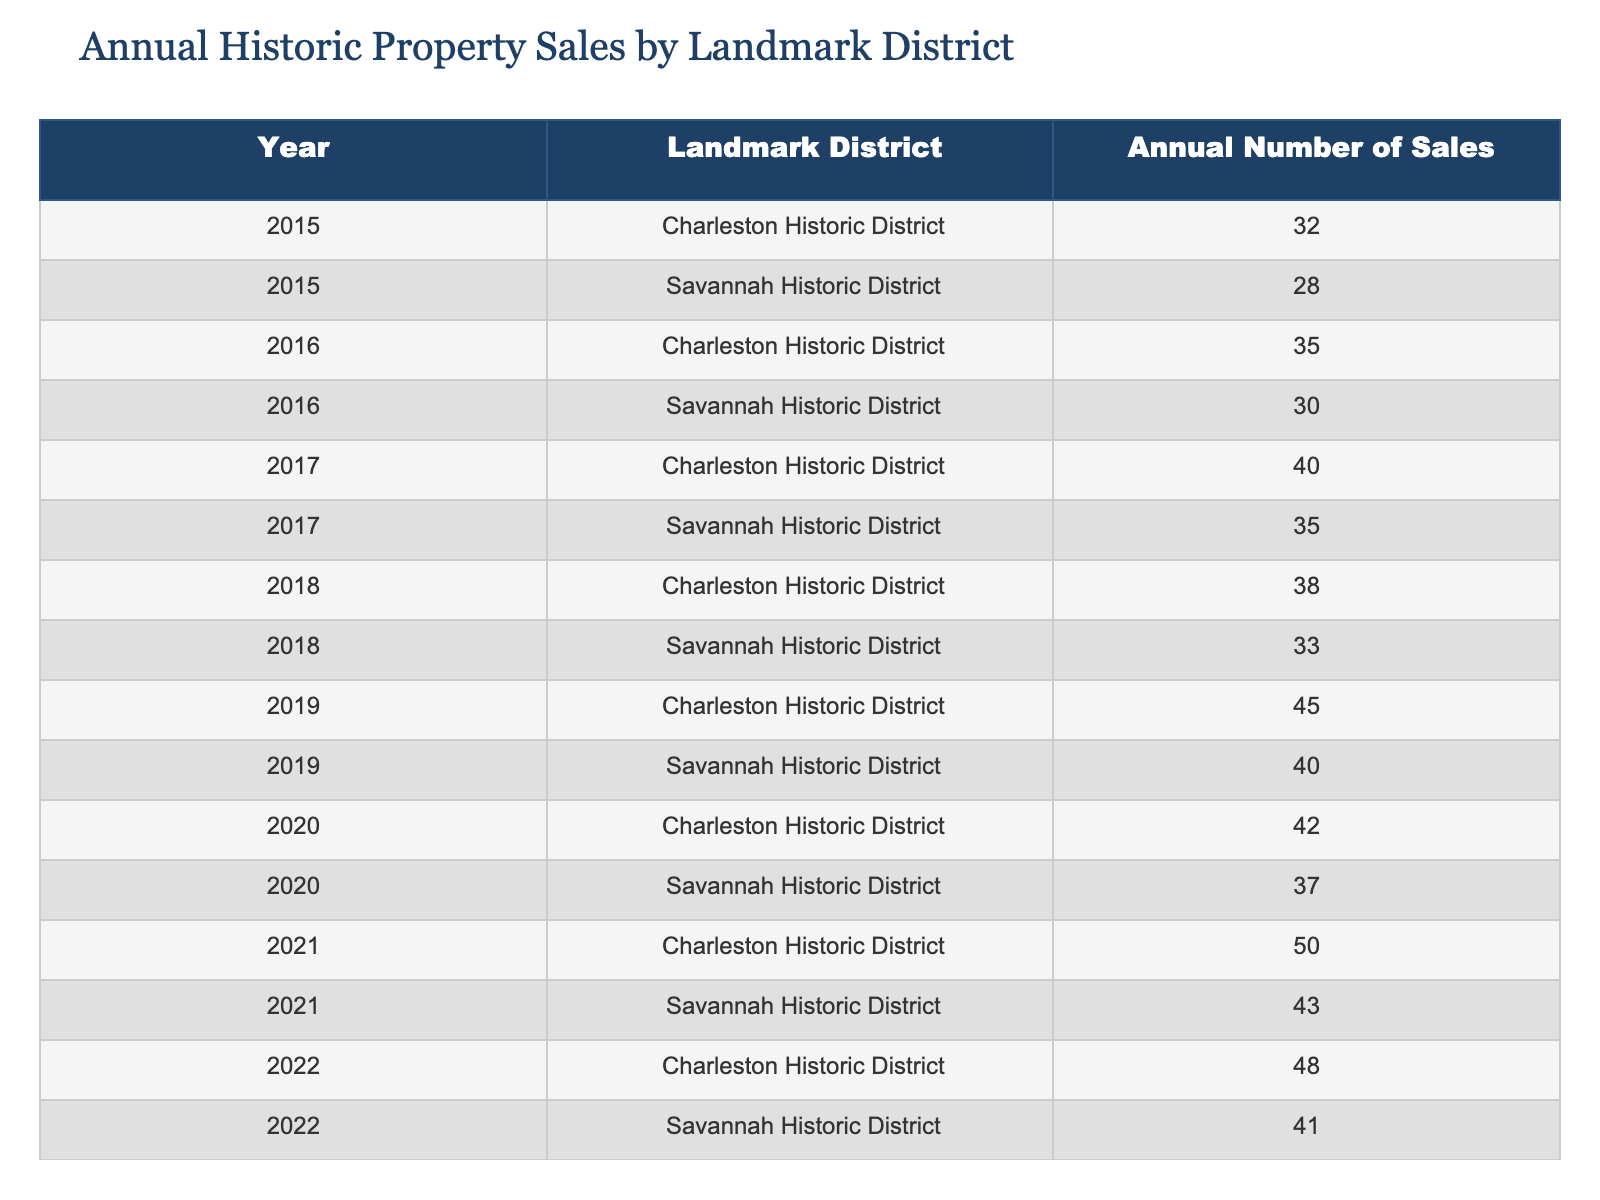What was the highest number of sales recorded in the Charleston Historic District? The data shows the number of sales for each year specifically for the Charleston Historic District. Looking through the numbers, the highest sale recorded is 55 in 2023.
Answer: 55 What was the total number of sales in Savannah Historic District from 2015 to 2023? To find the total, we add the annual sales for each year from the Savannah Historic District: 28 + 30 + 35 + 33 + 40 + 37 + 43 + 41 + 45 =  392.
Answer: 392 Was there an increase in sales in the Charleston Historic District from 2022 to 2023? The sales in 2022 were 48, and in 2023 they increased to 55. Since 55 is greater than 48, it indicates an increase.
Answer: Yes What is the average number of sales per year for the Savannah Historic District? To find the average, we first sum the sales: 28 + 30 + 35 + 33 + 40 + 37 + 43 + 41 + 45 = 392. Then, we divide that by the number of years, which is 9. So, 392 / 9 = 43.56, rounding gives approximately 44.
Answer: 44 In which year did the Charleston Historic District see its lowest sales, and what was the figure? By examining the table, we can see that the lowest number of sales for the Charleston Historic District occurred in 2015, with a total of 32 sales.
Answer: 2015, 32 How many more sales were recorded in the Charleston Historic District in 2021 compared to 2019? The sales in 2021 were 50, and in 2019 they were 45. The difference can be calculated as 50 - 45 = 5.
Answer: 5 Was the number of sales in the Charleston Historic District greater than in the Savannah Historic District for every year from 2015 to 2023? Reviewing the table, in every year from 2015 to 2023, the sales in the Charleston Historic District were consistently higher than those in Savannah.
Answer: Yes What year experienced the largest annual increase in sales for the Savannah Historic District? To find the largest increase, we examine the difference in sales year over year: (30 - 28), (35 - 30), (33 - 35), (40 - 33), (37 - 40), (43 - 37), (41 - 43), (45 - 41). The largest increase occurred from 2020 to 2021, showing an increase of 6 sales (43 - 37).
Answer: 2021, 6 In which district were the total sales higher in 2019? The total sales for the Charleston Historic District in 2019 were 45, and for Savannah, they were 40. Thus, Charleston had higher sales than Savannah in 2019.
Answer: Charleston 